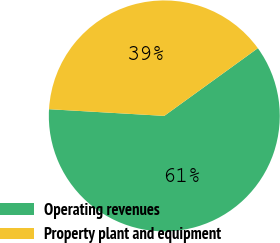Convert chart. <chart><loc_0><loc_0><loc_500><loc_500><pie_chart><fcel>Operating revenues<fcel>Property plant and equipment<nl><fcel>60.89%<fcel>39.11%<nl></chart> 